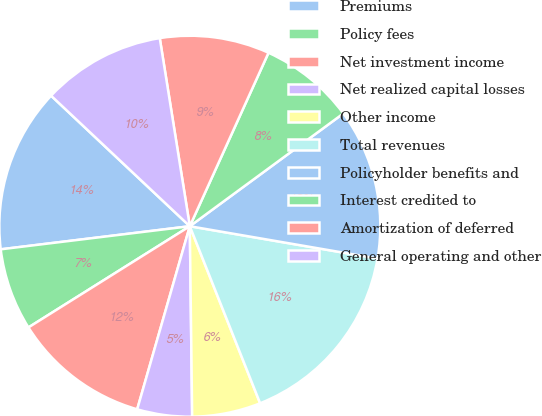<chart> <loc_0><loc_0><loc_500><loc_500><pie_chart><fcel>Premiums<fcel>Policy fees<fcel>Net investment income<fcel>Net realized capital losses<fcel>Other income<fcel>Total revenues<fcel>Policyholder benefits and<fcel>Interest credited to<fcel>Amortization of deferred<fcel>General operating and other<nl><fcel>13.95%<fcel>6.98%<fcel>11.63%<fcel>4.65%<fcel>5.82%<fcel>16.27%<fcel>12.79%<fcel>8.14%<fcel>9.3%<fcel>10.46%<nl></chart> 